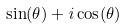Convert formula to latex. <formula><loc_0><loc_0><loc_500><loc_500>\sin ( \theta ) + i \cos ( \theta )</formula> 